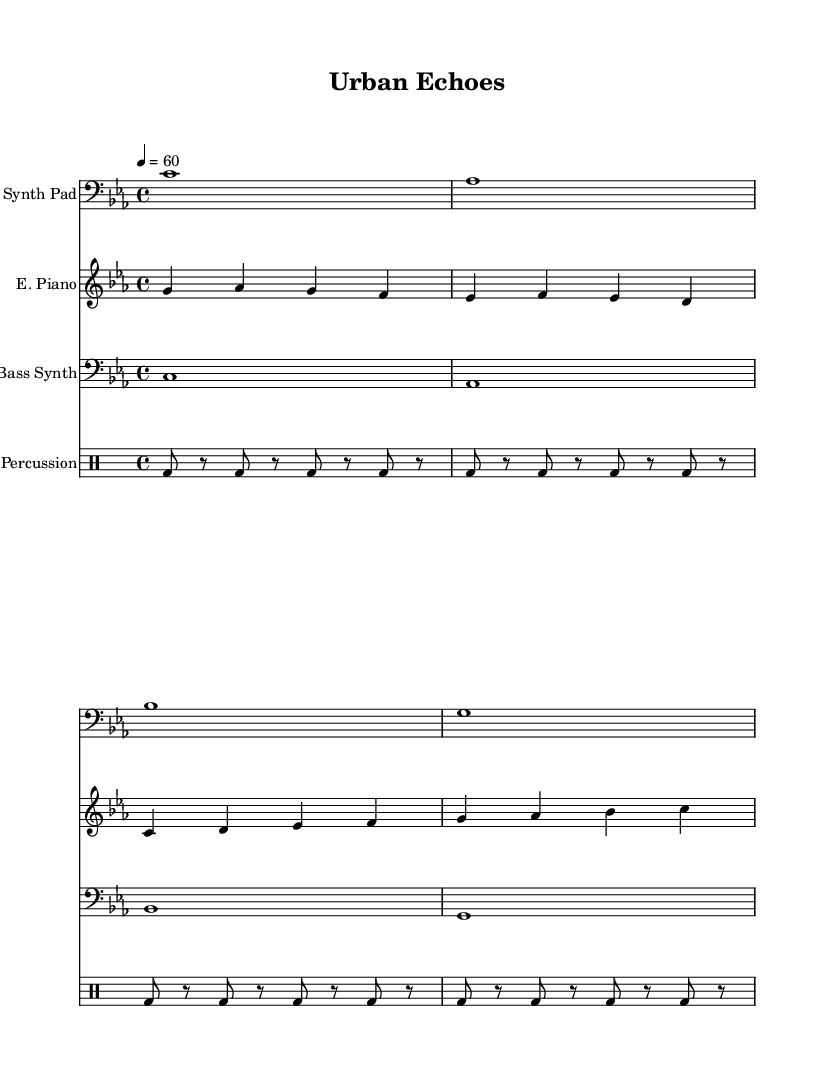What is the key signature of this music? The key signature indicated in the score is C minor, which consists of three flats: B flat, E flat, and A flat.
Answer: C minor What is the time signature of this music? The time signature is displayed as 4/4, which denotes that each measure contains four beats and the quarter note receives one beat.
Answer: 4/4 What is the tempo marking for this piece? The tempo marking in the score is indicated as "4 = 60," which means that there are 60 beats per minute and each quarter note gets one beat.
Answer: 60 How many measures does the electric piano part have? The electric piano part spans a total of four measures, as evidenced by the grouping of notes and the presence of bar lines.
Answer: 4 measures What is the function of the drum staff in this composition? The drum staff primarily provides a rhythmic foundation through the bass drum hits, creating a consistent pulse that complements the harmonic and melodic elements.
Answer: Rhythmic foundation What type of texture does this piece exhibit? The texture is considered polyphonic, as multiple independent melodic lines are combined, each with distinct rhythms and pitches, typical in ambient electronic music.
Answer: Polyphonic What instrument plays the lowest part in this arrangement? The bass synth plays the lowest part in the arrangement, as it is notated in the bass clef and has notes that are lower in pitch compared to the other instruments.
Answer: Bass Synth 